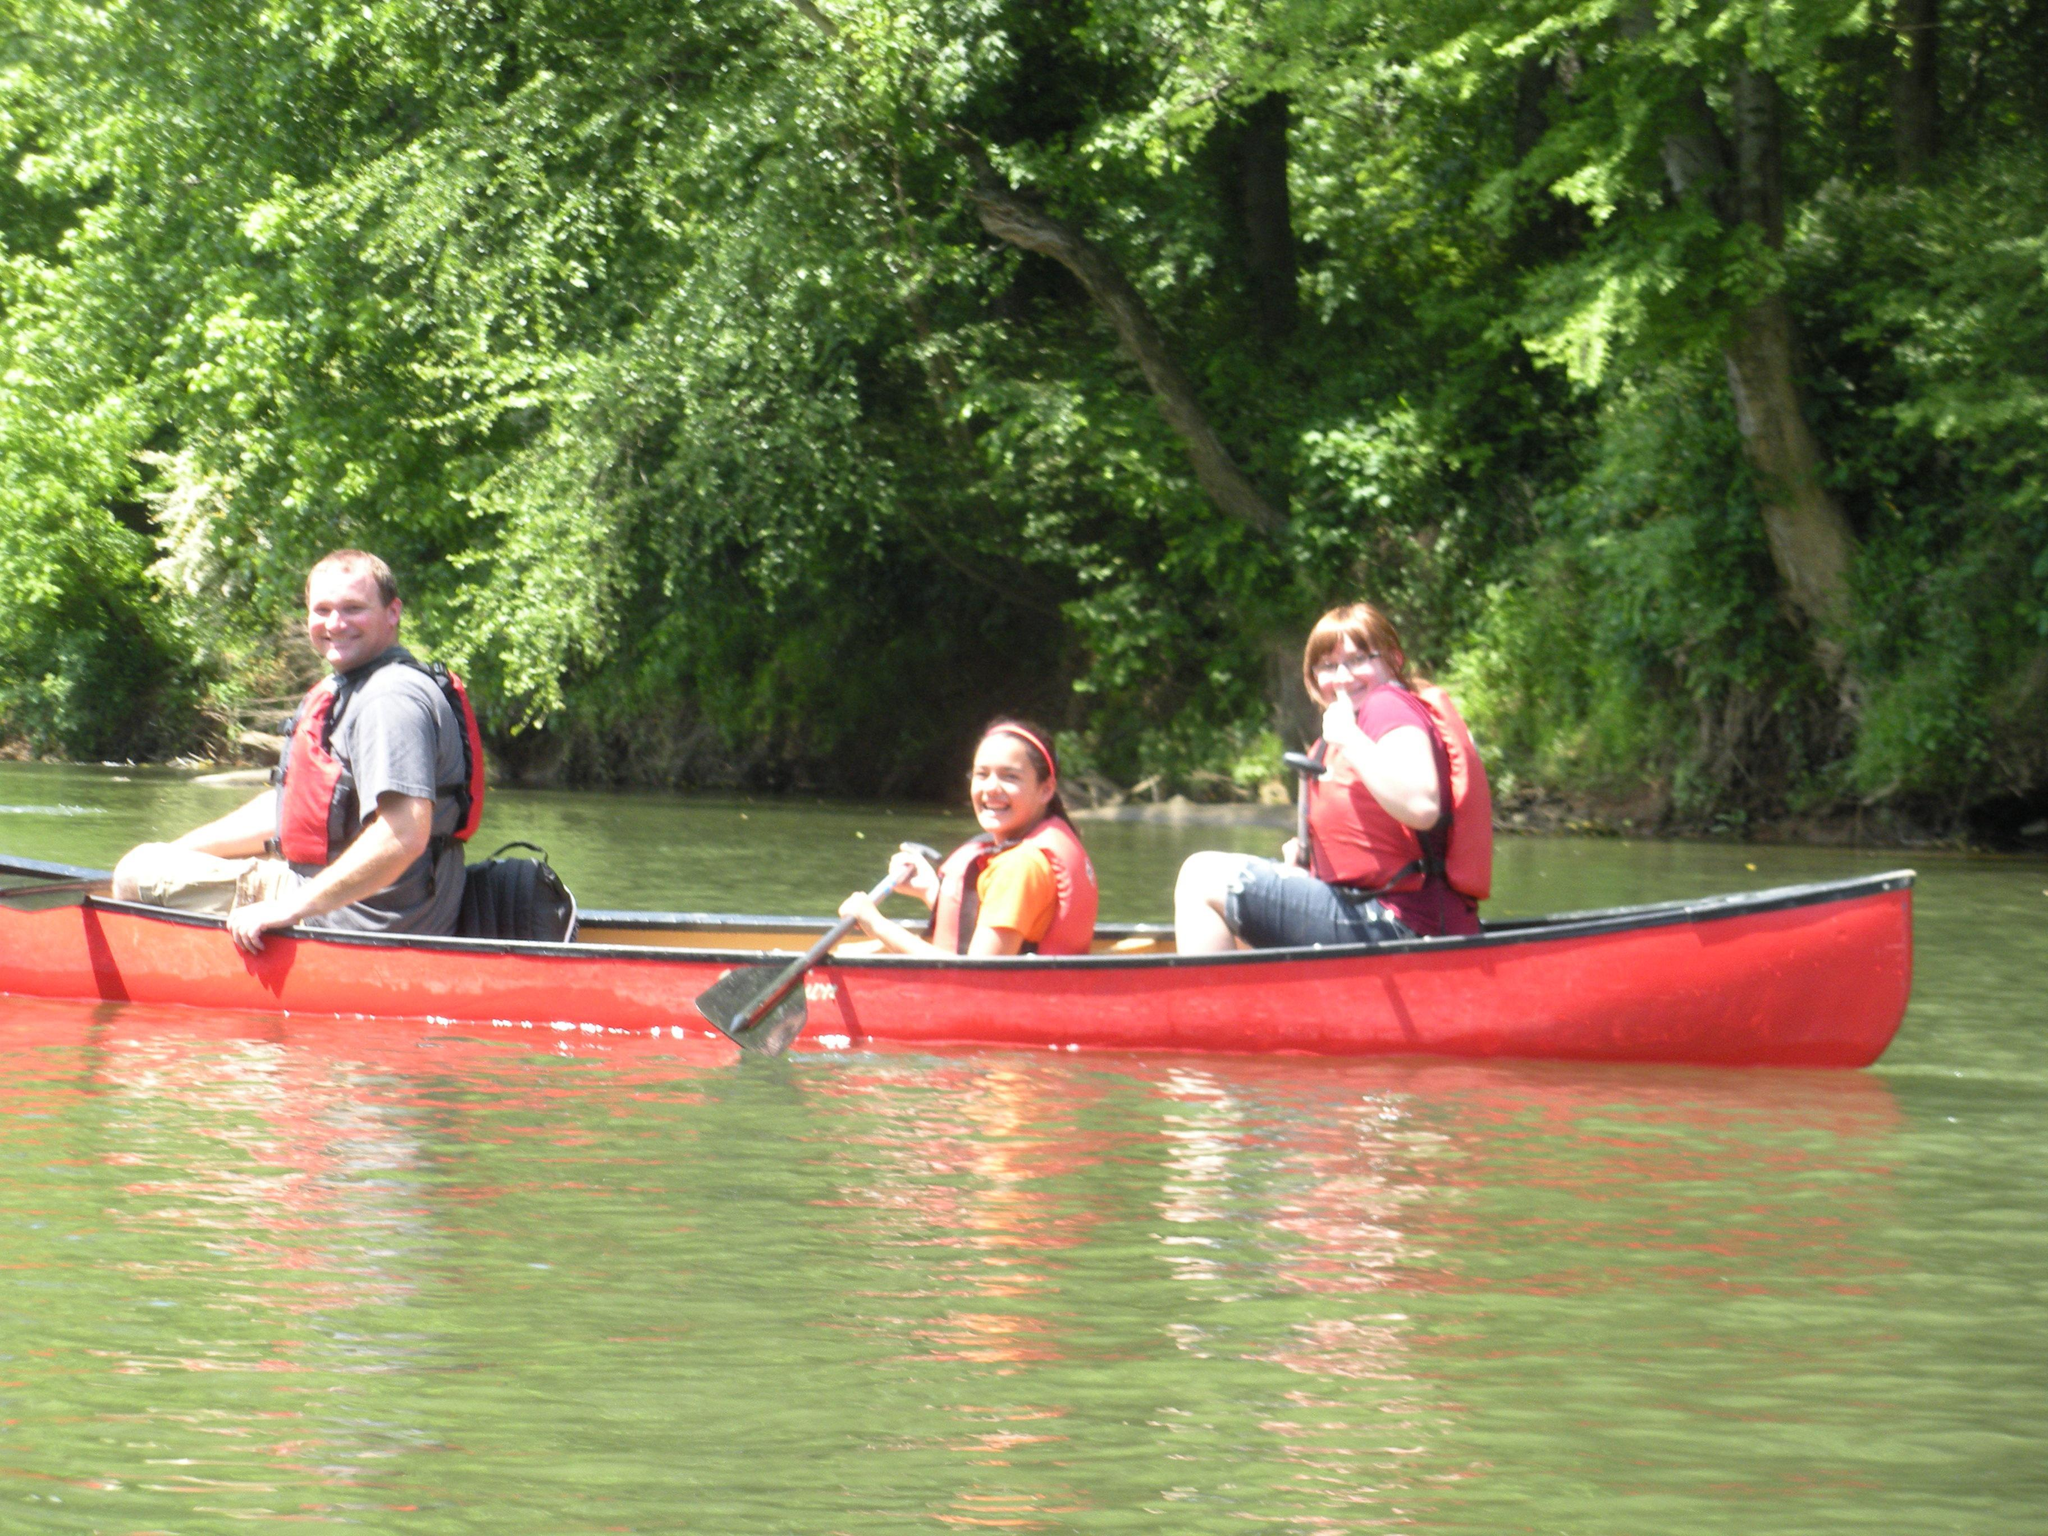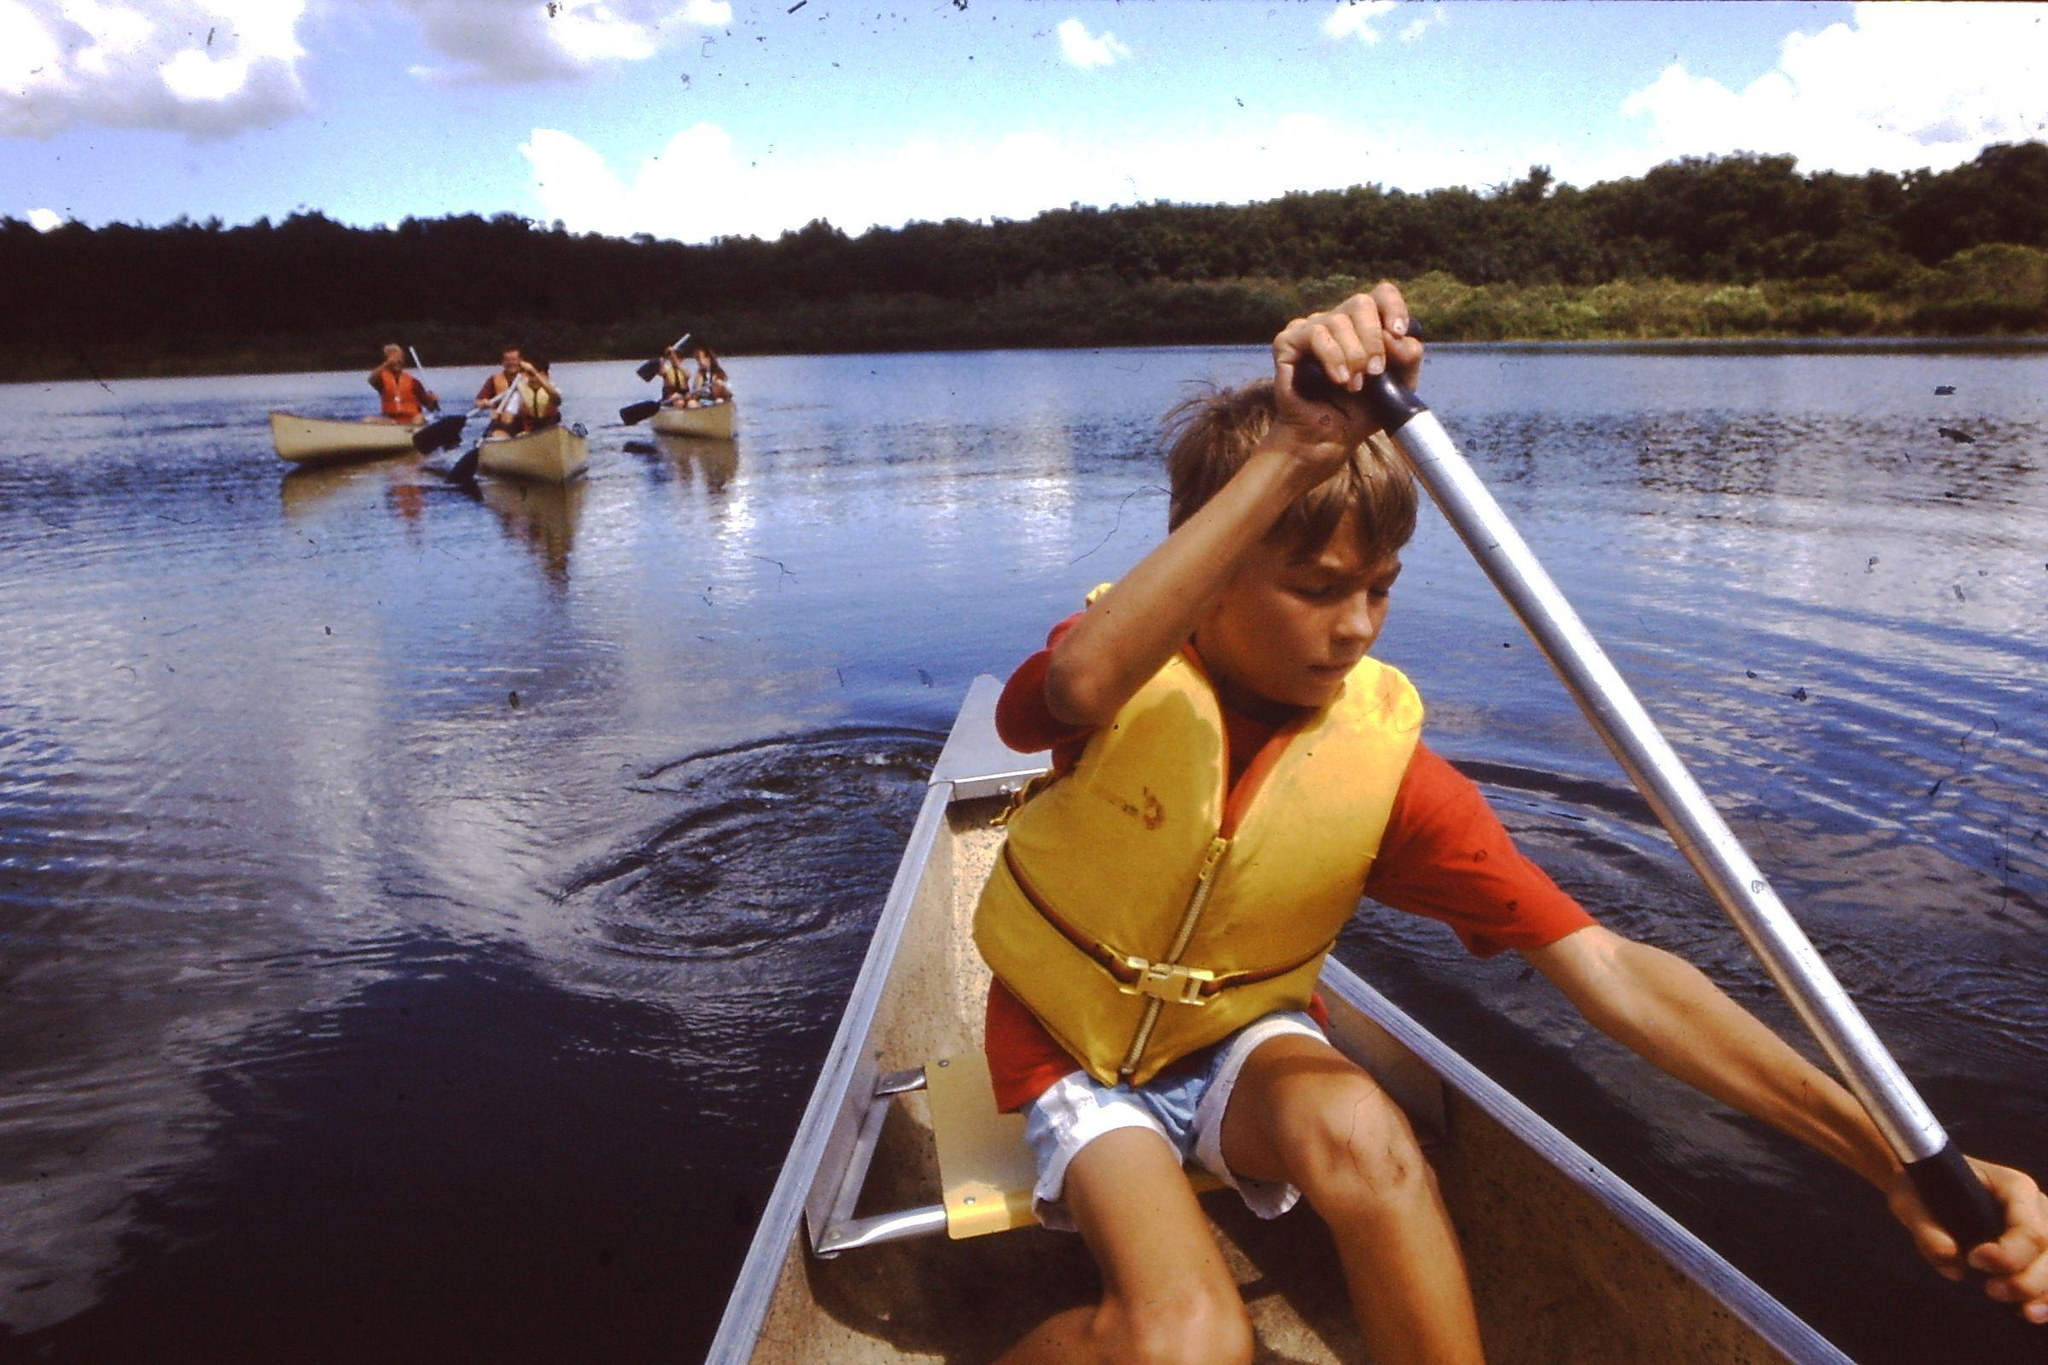The first image is the image on the left, the second image is the image on the right. Considering the images on both sides, is "The left image shows three people in a lefward-facing horizontal red-orange canoe." valid? Answer yes or no. Yes. The first image is the image on the left, the second image is the image on the right. Analyze the images presented: Is the assertion "In the red boat in the left image, there are three people." valid? Answer yes or no. Yes. 